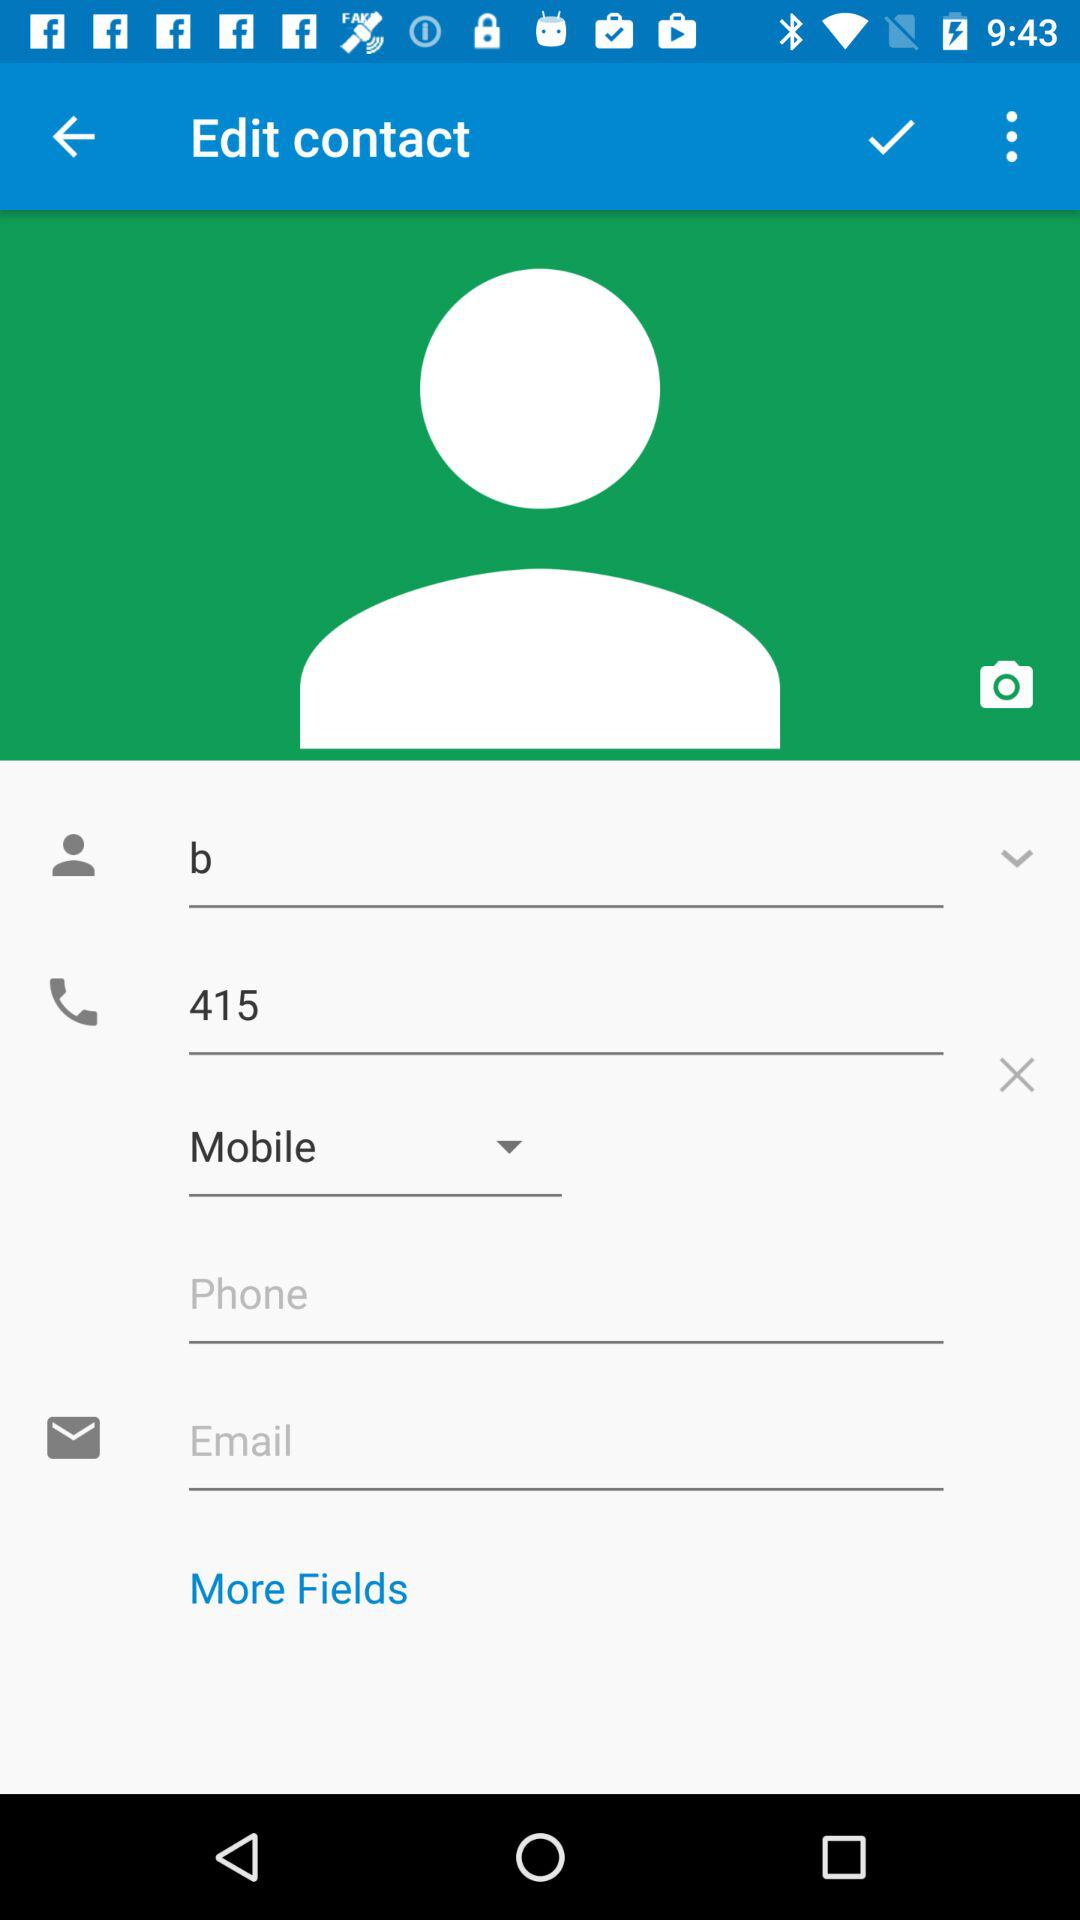What is the name? The name is "b". 